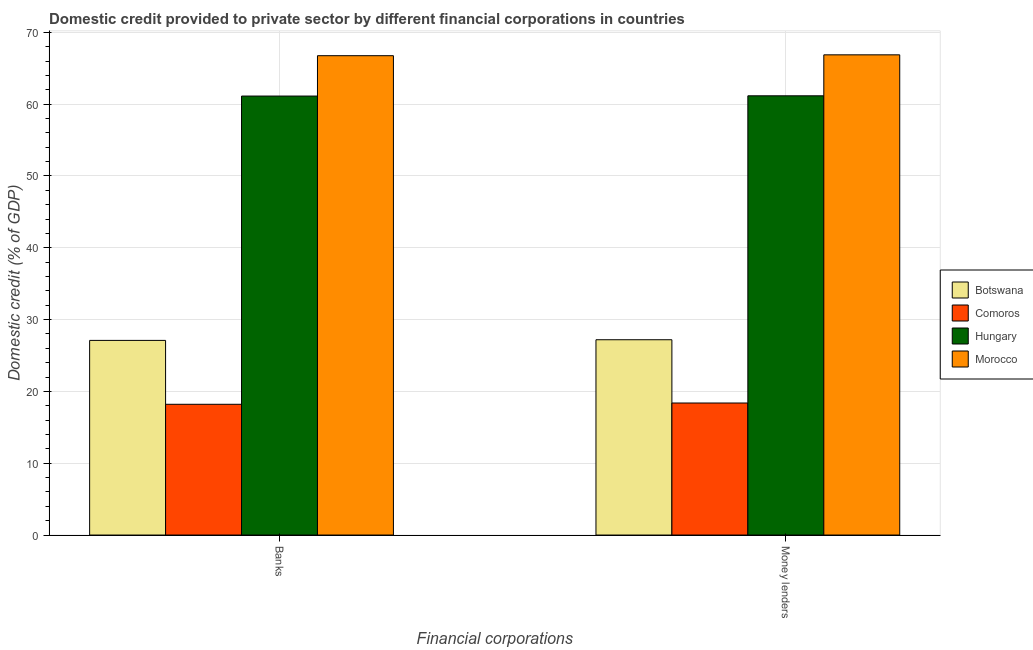How many different coloured bars are there?
Your response must be concise. 4. How many bars are there on the 1st tick from the left?
Provide a short and direct response. 4. What is the label of the 1st group of bars from the left?
Provide a succinct answer. Banks. What is the domestic credit provided by banks in Botswana?
Ensure brevity in your answer.  27.1. Across all countries, what is the maximum domestic credit provided by money lenders?
Ensure brevity in your answer.  66.86. Across all countries, what is the minimum domestic credit provided by money lenders?
Offer a terse response. 18.38. In which country was the domestic credit provided by money lenders maximum?
Offer a terse response. Morocco. In which country was the domestic credit provided by banks minimum?
Provide a short and direct response. Comoros. What is the total domestic credit provided by money lenders in the graph?
Your response must be concise. 173.6. What is the difference between the domestic credit provided by banks in Comoros and that in Botswana?
Offer a terse response. -8.9. What is the difference between the domestic credit provided by money lenders in Comoros and the domestic credit provided by banks in Hungary?
Provide a succinct answer. -42.74. What is the average domestic credit provided by banks per country?
Your answer should be very brief. 43.29. What is the difference between the domestic credit provided by banks and domestic credit provided by money lenders in Morocco?
Your answer should be compact. -0.12. What is the ratio of the domestic credit provided by money lenders in Botswana to that in Comoros?
Make the answer very short. 1.48. What does the 2nd bar from the left in Banks represents?
Your answer should be compact. Comoros. What does the 4th bar from the right in Money lenders represents?
Offer a terse response. Botswana. How many bars are there?
Provide a short and direct response. 8. Are the values on the major ticks of Y-axis written in scientific E-notation?
Give a very brief answer. No. Does the graph contain any zero values?
Make the answer very short. No. Does the graph contain grids?
Provide a succinct answer. Yes. How are the legend labels stacked?
Your answer should be compact. Vertical. What is the title of the graph?
Your answer should be very brief. Domestic credit provided to private sector by different financial corporations in countries. What is the label or title of the X-axis?
Your answer should be compact. Financial corporations. What is the label or title of the Y-axis?
Offer a very short reply. Domestic credit (% of GDP). What is the Domestic credit (% of GDP) in Botswana in Banks?
Your answer should be very brief. 27.1. What is the Domestic credit (% of GDP) of Comoros in Banks?
Offer a very short reply. 18.21. What is the Domestic credit (% of GDP) of Hungary in Banks?
Ensure brevity in your answer.  61.12. What is the Domestic credit (% of GDP) of Morocco in Banks?
Make the answer very short. 66.74. What is the Domestic credit (% of GDP) of Botswana in Money lenders?
Keep it short and to the point. 27.19. What is the Domestic credit (% of GDP) of Comoros in Money lenders?
Provide a succinct answer. 18.38. What is the Domestic credit (% of GDP) in Hungary in Money lenders?
Offer a very short reply. 61.16. What is the Domestic credit (% of GDP) in Morocco in Money lenders?
Keep it short and to the point. 66.86. Across all Financial corporations, what is the maximum Domestic credit (% of GDP) in Botswana?
Provide a short and direct response. 27.19. Across all Financial corporations, what is the maximum Domestic credit (% of GDP) of Comoros?
Keep it short and to the point. 18.38. Across all Financial corporations, what is the maximum Domestic credit (% of GDP) of Hungary?
Provide a succinct answer. 61.16. Across all Financial corporations, what is the maximum Domestic credit (% of GDP) of Morocco?
Keep it short and to the point. 66.86. Across all Financial corporations, what is the minimum Domestic credit (% of GDP) in Botswana?
Your answer should be very brief. 27.1. Across all Financial corporations, what is the minimum Domestic credit (% of GDP) in Comoros?
Provide a succinct answer. 18.21. Across all Financial corporations, what is the minimum Domestic credit (% of GDP) of Hungary?
Make the answer very short. 61.12. Across all Financial corporations, what is the minimum Domestic credit (% of GDP) of Morocco?
Your response must be concise. 66.74. What is the total Domestic credit (% of GDP) in Botswana in the graph?
Your answer should be very brief. 54.3. What is the total Domestic credit (% of GDP) of Comoros in the graph?
Make the answer very short. 36.59. What is the total Domestic credit (% of GDP) of Hungary in the graph?
Keep it short and to the point. 122.28. What is the total Domestic credit (% of GDP) of Morocco in the graph?
Offer a very short reply. 133.61. What is the difference between the Domestic credit (% of GDP) of Botswana in Banks and that in Money lenders?
Offer a very short reply. -0.09. What is the difference between the Domestic credit (% of GDP) of Comoros in Banks and that in Money lenders?
Ensure brevity in your answer.  -0.18. What is the difference between the Domestic credit (% of GDP) in Hungary in Banks and that in Money lenders?
Provide a short and direct response. -0.04. What is the difference between the Domestic credit (% of GDP) of Morocco in Banks and that in Money lenders?
Provide a short and direct response. -0.12. What is the difference between the Domestic credit (% of GDP) of Botswana in Banks and the Domestic credit (% of GDP) of Comoros in Money lenders?
Give a very brief answer. 8.72. What is the difference between the Domestic credit (% of GDP) in Botswana in Banks and the Domestic credit (% of GDP) in Hungary in Money lenders?
Give a very brief answer. -34.06. What is the difference between the Domestic credit (% of GDP) of Botswana in Banks and the Domestic credit (% of GDP) of Morocco in Money lenders?
Your answer should be compact. -39.76. What is the difference between the Domestic credit (% of GDP) of Comoros in Banks and the Domestic credit (% of GDP) of Hungary in Money lenders?
Provide a short and direct response. -42.95. What is the difference between the Domestic credit (% of GDP) of Comoros in Banks and the Domestic credit (% of GDP) of Morocco in Money lenders?
Provide a succinct answer. -48.66. What is the difference between the Domestic credit (% of GDP) in Hungary in Banks and the Domestic credit (% of GDP) in Morocco in Money lenders?
Your response must be concise. -5.74. What is the average Domestic credit (% of GDP) of Botswana per Financial corporations?
Your answer should be very brief. 27.15. What is the average Domestic credit (% of GDP) in Comoros per Financial corporations?
Provide a short and direct response. 18.3. What is the average Domestic credit (% of GDP) of Hungary per Financial corporations?
Provide a short and direct response. 61.14. What is the average Domestic credit (% of GDP) of Morocco per Financial corporations?
Your answer should be very brief. 66.8. What is the difference between the Domestic credit (% of GDP) of Botswana and Domestic credit (% of GDP) of Comoros in Banks?
Your response must be concise. 8.9. What is the difference between the Domestic credit (% of GDP) of Botswana and Domestic credit (% of GDP) of Hungary in Banks?
Ensure brevity in your answer.  -34.02. What is the difference between the Domestic credit (% of GDP) of Botswana and Domestic credit (% of GDP) of Morocco in Banks?
Your answer should be very brief. -39.64. What is the difference between the Domestic credit (% of GDP) of Comoros and Domestic credit (% of GDP) of Hungary in Banks?
Provide a succinct answer. -42.92. What is the difference between the Domestic credit (% of GDP) in Comoros and Domestic credit (% of GDP) in Morocco in Banks?
Provide a short and direct response. -48.54. What is the difference between the Domestic credit (% of GDP) in Hungary and Domestic credit (% of GDP) in Morocco in Banks?
Provide a short and direct response. -5.62. What is the difference between the Domestic credit (% of GDP) of Botswana and Domestic credit (% of GDP) of Comoros in Money lenders?
Ensure brevity in your answer.  8.81. What is the difference between the Domestic credit (% of GDP) of Botswana and Domestic credit (% of GDP) of Hungary in Money lenders?
Ensure brevity in your answer.  -33.97. What is the difference between the Domestic credit (% of GDP) of Botswana and Domestic credit (% of GDP) of Morocco in Money lenders?
Give a very brief answer. -39.67. What is the difference between the Domestic credit (% of GDP) of Comoros and Domestic credit (% of GDP) of Hungary in Money lenders?
Make the answer very short. -42.77. What is the difference between the Domestic credit (% of GDP) in Comoros and Domestic credit (% of GDP) in Morocco in Money lenders?
Keep it short and to the point. -48.48. What is the difference between the Domestic credit (% of GDP) of Hungary and Domestic credit (% of GDP) of Morocco in Money lenders?
Provide a short and direct response. -5.7. What is the ratio of the Domestic credit (% of GDP) of Botswana in Banks to that in Money lenders?
Provide a short and direct response. 1. What is the ratio of the Domestic credit (% of GDP) in Comoros in Banks to that in Money lenders?
Offer a terse response. 0.99. What is the ratio of the Domestic credit (% of GDP) of Hungary in Banks to that in Money lenders?
Offer a very short reply. 1. What is the difference between the highest and the second highest Domestic credit (% of GDP) of Botswana?
Give a very brief answer. 0.09. What is the difference between the highest and the second highest Domestic credit (% of GDP) in Comoros?
Offer a very short reply. 0.18. What is the difference between the highest and the second highest Domestic credit (% of GDP) of Hungary?
Your response must be concise. 0.04. What is the difference between the highest and the second highest Domestic credit (% of GDP) in Morocco?
Ensure brevity in your answer.  0.12. What is the difference between the highest and the lowest Domestic credit (% of GDP) of Botswana?
Your response must be concise. 0.09. What is the difference between the highest and the lowest Domestic credit (% of GDP) of Comoros?
Your answer should be very brief. 0.18. What is the difference between the highest and the lowest Domestic credit (% of GDP) in Hungary?
Offer a very short reply. 0.04. What is the difference between the highest and the lowest Domestic credit (% of GDP) in Morocco?
Keep it short and to the point. 0.12. 